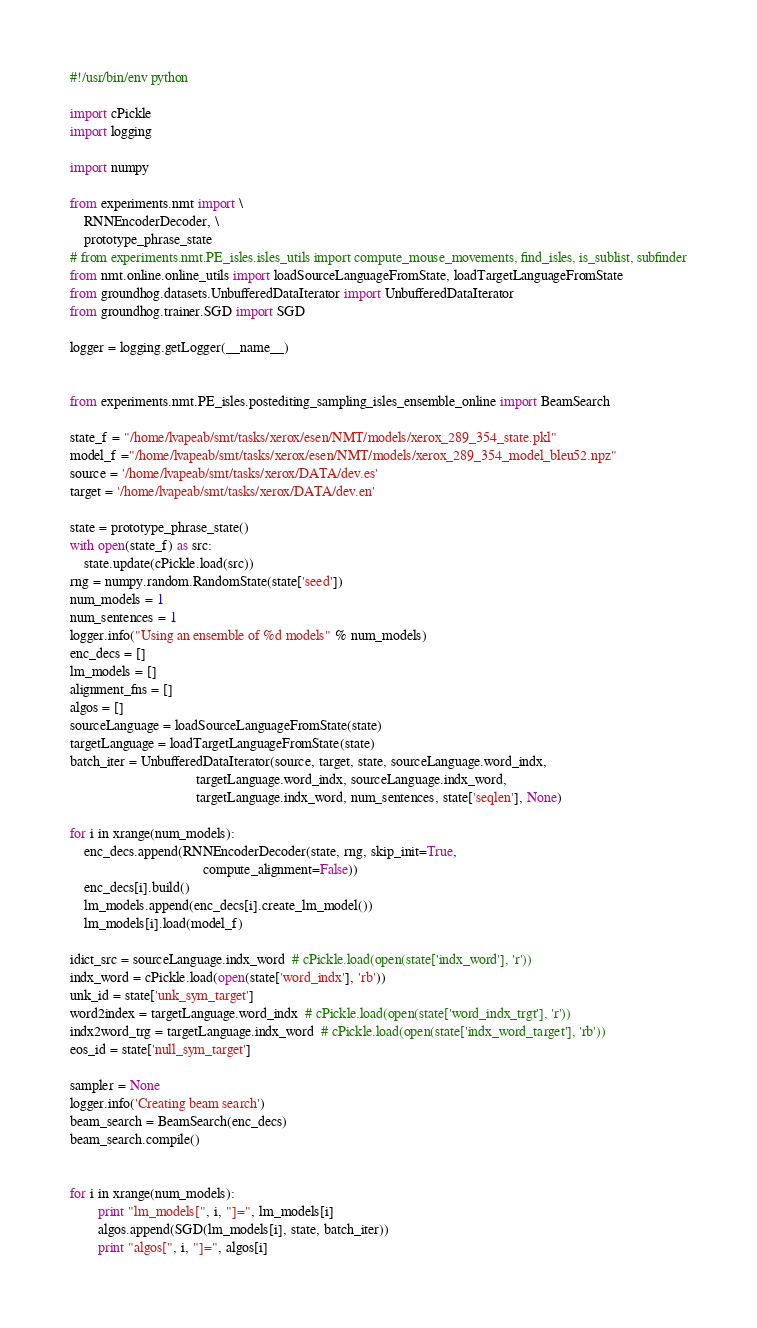<code> <loc_0><loc_0><loc_500><loc_500><_Python_>#!/usr/bin/env python

import cPickle
import logging

import numpy

from experiments.nmt import \
    RNNEncoderDecoder, \
    prototype_phrase_state
# from experiments.nmt.PE_isles.isles_utils import compute_mouse_movements, find_isles, is_sublist, subfinder
from nmt.online.online_utils import loadSourceLanguageFromState, loadTargetLanguageFromState
from groundhog.datasets.UnbufferedDataIterator import UnbufferedDataIterator
from groundhog.trainer.SGD import SGD

logger = logging.getLogger(__name__)


from experiments.nmt.PE_isles.postediting_sampling_isles_ensemble_online import BeamSearch

state_f = "/home/lvapeab/smt/tasks/xerox/esen/NMT/models/xerox_289_354_state.pkl"
model_f ="/home/lvapeab/smt/tasks/xerox/esen/NMT/models/xerox_289_354_model_bleu52.npz"
source = '/home/lvapeab/smt/tasks/xerox/DATA/dev.es'
target = '/home/lvapeab/smt/tasks/xerox/DATA/dev.en'

state = prototype_phrase_state()
with open(state_f) as src:
    state.update(cPickle.load(src))
rng = numpy.random.RandomState(state['seed'])
num_models = 1
num_sentences = 1
logger.info("Using an ensemble of %d models" % num_models)
enc_decs = []
lm_models = []
alignment_fns = []
algos = []
sourceLanguage = loadSourceLanguageFromState(state)
targetLanguage = loadTargetLanguageFromState(state)
batch_iter = UnbufferedDataIterator(source, target, state, sourceLanguage.word_indx,
                                    targetLanguage.word_indx, sourceLanguage.indx_word,
                                    targetLanguage.indx_word, num_sentences, state['seqlen'], None)

for i in xrange(num_models):
    enc_decs.append(RNNEncoderDecoder(state, rng, skip_init=True,
                                      compute_alignment=False))
    enc_decs[i].build()
    lm_models.append(enc_decs[i].create_lm_model())
    lm_models[i].load(model_f)

idict_src = sourceLanguage.indx_word  # cPickle.load(open(state['indx_word'], 'r'))
indx_word = cPickle.load(open(state['word_indx'], 'rb'))
unk_id = state['unk_sym_target']
word2index = targetLanguage.word_indx  # cPickle.load(open(state['word_indx_trgt'], 'r'))
indx2word_trg = targetLanguage.indx_word  # cPickle.load(open(state['indx_word_target'], 'rb'))
eos_id = state['null_sym_target']

sampler = None
logger.info('Creating beam search')
beam_search = BeamSearch(enc_decs)
beam_search.compile()


for i in xrange(num_models):
        print "lm_models[", i, "]=", lm_models[i]
        algos.append(SGD(lm_models[i], state, batch_iter))
        print "algos[", i, "]=", algos[i]
</code> 